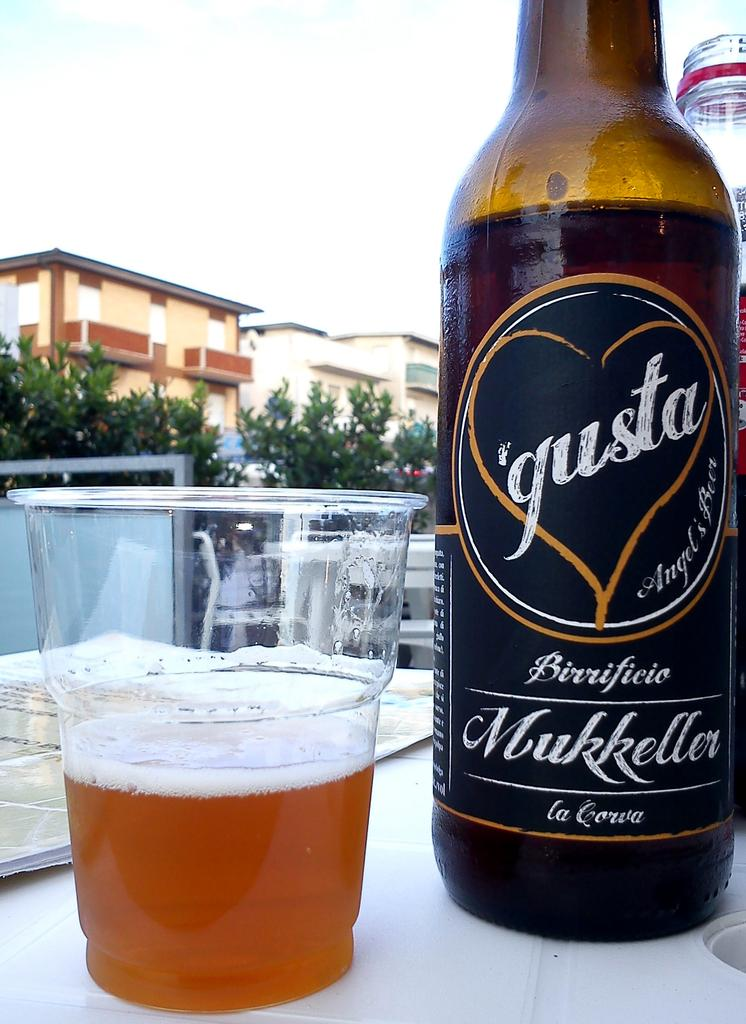<image>
Write a terse but informative summary of the picture. The bottle of gusta beer is next to a half full plastic cup of beer. 